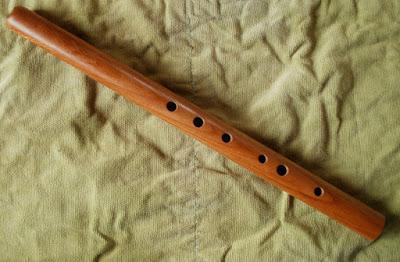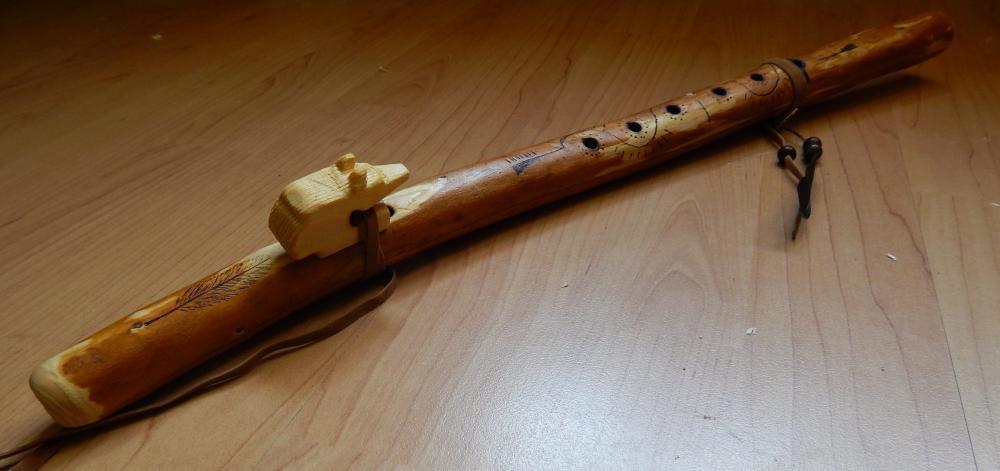The first image is the image on the left, the second image is the image on the right. Examine the images to the left and right. Is the description "there are two flutes in the image pair" accurate? Answer yes or no. Yes. The first image is the image on the left, the second image is the image on the right. Assess this claim about the two images: "Each image contains one perforated, stick-like instrument displayed at an angle, and the right image shows an instrument with a leather tie on one end.". Correct or not? Answer yes or no. Yes. 